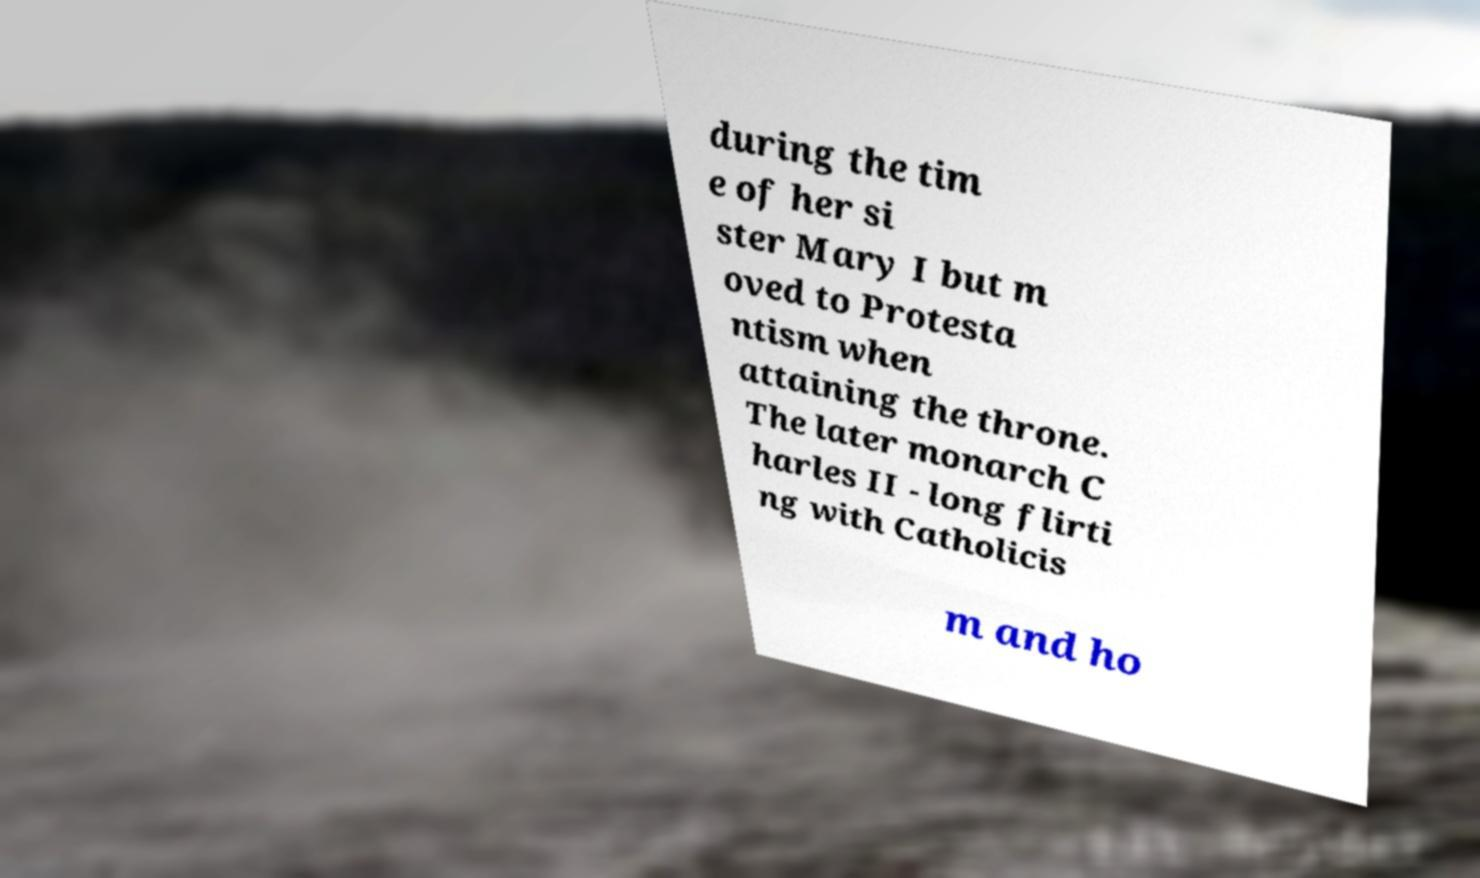Could you extract and type out the text from this image? during the tim e of her si ster Mary I but m oved to Protesta ntism when attaining the throne. The later monarch C harles II - long flirti ng with Catholicis m and ho 